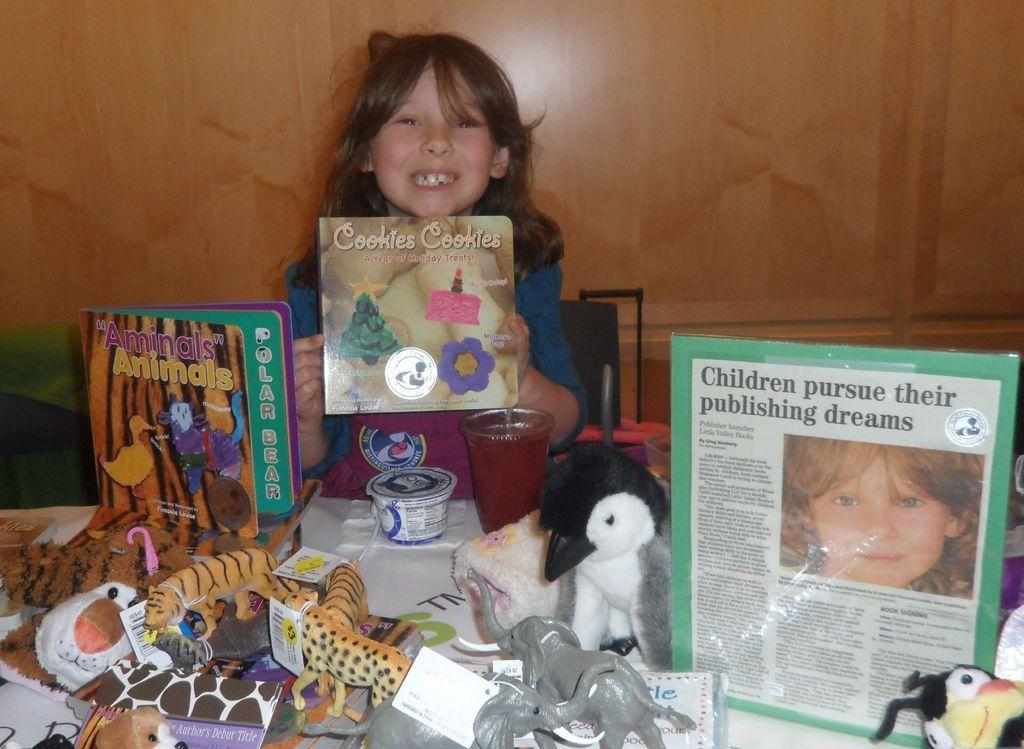Who is the main subject in the image? There is a small girl in the center of the image. What is the girl holding in her hands? The girl is holding a cookies box in her hands. What can be seen in front of the girl? There are toys and books in front of the girl. What type of texture can be seen on the girl's swimsuit in the image? There is no swimsuit present in the image, and therefore no texture can be observed. 